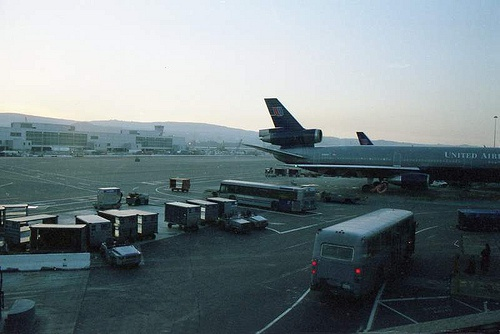Describe the objects in this image and their specific colors. I can see airplane in white, black, blue, darkblue, and teal tones, bus in white, black, gray, blue, and darkblue tones, bus in white, black, purple, teal, and darkblue tones, truck in white, black, gray, and darkblue tones, and truck in white, black, darkblue, and blue tones in this image. 